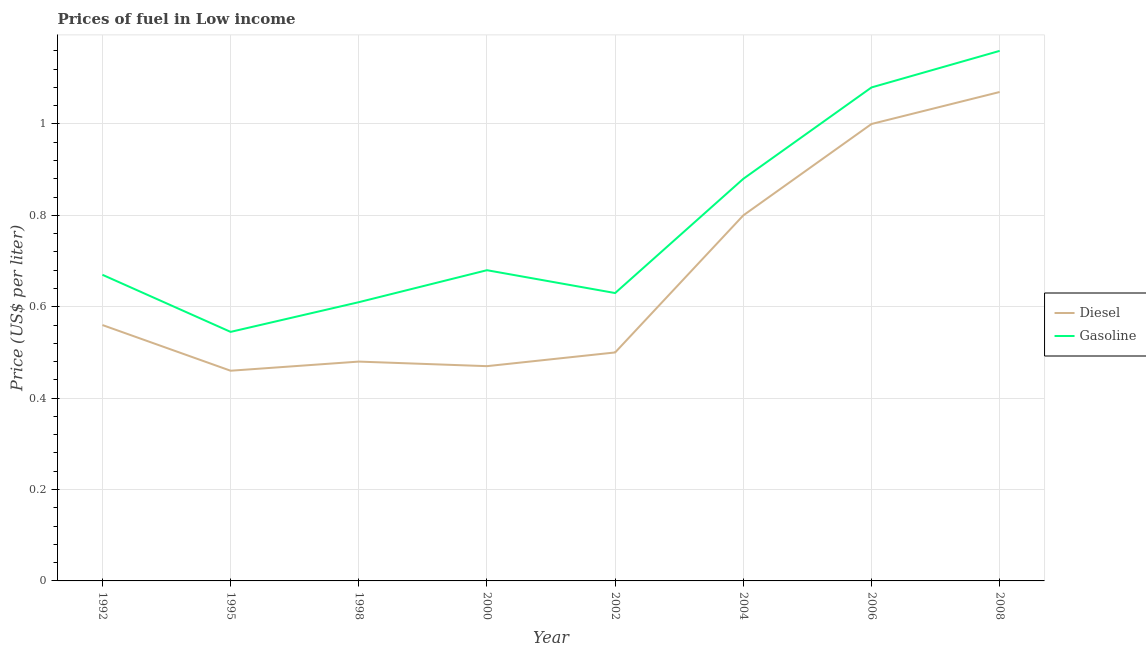How many different coloured lines are there?
Your answer should be compact. 2. What is the diesel price in 1992?
Make the answer very short. 0.56. Across all years, what is the maximum gasoline price?
Offer a very short reply. 1.16. Across all years, what is the minimum diesel price?
Provide a succinct answer. 0.46. In which year was the gasoline price maximum?
Your answer should be very brief. 2008. What is the total gasoline price in the graph?
Provide a short and direct response. 6.25. What is the difference between the gasoline price in 2002 and that in 2006?
Ensure brevity in your answer.  -0.45. What is the difference between the gasoline price in 1992 and the diesel price in 2000?
Ensure brevity in your answer.  0.2. What is the average diesel price per year?
Your answer should be compact. 0.67. In the year 2004, what is the difference between the diesel price and gasoline price?
Offer a very short reply. -0.08. In how many years, is the diesel price greater than 0.8 US$ per litre?
Your response must be concise. 2. What is the ratio of the diesel price in 1995 to that in 1998?
Your answer should be very brief. 0.96. Is the diesel price in 1995 less than that in 2002?
Your answer should be compact. Yes. Is the difference between the gasoline price in 2002 and 2008 greater than the difference between the diesel price in 2002 and 2008?
Offer a very short reply. Yes. What is the difference between the highest and the second highest gasoline price?
Make the answer very short. 0.08. What is the difference between the highest and the lowest gasoline price?
Make the answer very short. 0.61. Does the diesel price monotonically increase over the years?
Make the answer very short. No. Is the gasoline price strictly greater than the diesel price over the years?
Make the answer very short. Yes. Is the gasoline price strictly less than the diesel price over the years?
Provide a short and direct response. No. How many lines are there?
Provide a short and direct response. 2. Does the graph contain grids?
Make the answer very short. Yes. How are the legend labels stacked?
Your answer should be very brief. Vertical. What is the title of the graph?
Offer a very short reply. Prices of fuel in Low income. What is the label or title of the Y-axis?
Give a very brief answer. Price (US$ per liter). What is the Price (US$ per liter) in Diesel in 1992?
Ensure brevity in your answer.  0.56. What is the Price (US$ per liter) in Gasoline in 1992?
Your answer should be compact. 0.67. What is the Price (US$ per liter) of Diesel in 1995?
Offer a very short reply. 0.46. What is the Price (US$ per liter) of Gasoline in 1995?
Offer a terse response. 0.55. What is the Price (US$ per liter) in Diesel in 1998?
Provide a succinct answer. 0.48. What is the Price (US$ per liter) in Gasoline in 1998?
Offer a terse response. 0.61. What is the Price (US$ per liter) in Diesel in 2000?
Your answer should be very brief. 0.47. What is the Price (US$ per liter) in Gasoline in 2000?
Provide a succinct answer. 0.68. What is the Price (US$ per liter) in Gasoline in 2002?
Offer a terse response. 0.63. What is the Price (US$ per liter) in Gasoline in 2004?
Your answer should be very brief. 0.88. What is the Price (US$ per liter) of Diesel in 2006?
Make the answer very short. 1. What is the Price (US$ per liter) in Gasoline in 2006?
Your response must be concise. 1.08. What is the Price (US$ per liter) of Diesel in 2008?
Ensure brevity in your answer.  1.07. What is the Price (US$ per liter) of Gasoline in 2008?
Provide a short and direct response. 1.16. Across all years, what is the maximum Price (US$ per liter) in Diesel?
Make the answer very short. 1.07. Across all years, what is the maximum Price (US$ per liter) of Gasoline?
Ensure brevity in your answer.  1.16. Across all years, what is the minimum Price (US$ per liter) of Diesel?
Give a very brief answer. 0.46. Across all years, what is the minimum Price (US$ per liter) in Gasoline?
Your answer should be compact. 0.55. What is the total Price (US$ per liter) in Diesel in the graph?
Provide a short and direct response. 5.34. What is the total Price (US$ per liter) of Gasoline in the graph?
Provide a succinct answer. 6.25. What is the difference between the Price (US$ per liter) in Gasoline in 1992 and that in 1995?
Give a very brief answer. 0.12. What is the difference between the Price (US$ per liter) in Gasoline in 1992 and that in 1998?
Provide a succinct answer. 0.06. What is the difference between the Price (US$ per liter) of Diesel in 1992 and that in 2000?
Provide a short and direct response. 0.09. What is the difference between the Price (US$ per liter) of Gasoline in 1992 and that in 2000?
Your answer should be compact. -0.01. What is the difference between the Price (US$ per liter) in Diesel in 1992 and that in 2002?
Ensure brevity in your answer.  0.06. What is the difference between the Price (US$ per liter) in Gasoline in 1992 and that in 2002?
Give a very brief answer. 0.04. What is the difference between the Price (US$ per liter) in Diesel in 1992 and that in 2004?
Your answer should be compact. -0.24. What is the difference between the Price (US$ per liter) in Gasoline in 1992 and that in 2004?
Keep it short and to the point. -0.21. What is the difference between the Price (US$ per liter) of Diesel in 1992 and that in 2006?
Offer a very short reply. -0.44. What is the difference between the Price (US$ per liter) of Gasoline in 1992 and that in 2006?
Offer a very short reply. -0.41. What is the difference between the Price (US$ per liter) in Diesel in 1992 and that in 2008?
Your answer should be very brief. -0.51. What is the difference between the Price (US$ per liter) of Gasoline in 1992 and that in 2008?
Your response must be concise. -0.49. What is the difference between the Price (US$ per liter) in Diesel in 1995 and that in 1998?
Your response must be concise. -0.02. What is the difference between the Price (US$ per liter) of Gasoline in 1995 and that in 1998?
Keep it short and to the point. -0.07. What is the difference between the Price (US$ per liter) in Diesel in 1995 and that in 2000?
Your response must be concise. -0.01. What is the difference between the Price (US$ per liter) of Gasoline in 1995 and that in 2000?
Provide a succinct answer. -0.14. What is the difference between the Price (US$ per liter) in Diesel in 1995 and that in 2002?
Your answer should be very brief. -0.04. What is the difference between the Price (US$ per liter) of Gasoline in 1995 and that in 2002?
Give a very brief answer. -0.09. What is the difference between the Price (US$ per liter) in Diesel in 1995 and that in 2004?
Ensure brevity in your answer.  -0.34. What is the difference between the Price (US$ per liter) in Gasoline in 1995 and that in 2004?
Your response must be concise. -0.34. What is the difference between the Price (US$ per liter) of Diesel in 1995 and that in 2006?
Keep it short and to the point. -0.54. What is the difference between the Price (US$ per liter) of Gasoline in 1995 and that in 2006?
Provide a short and direct response. -0.54. What is the difference between the Price (US$ per liter) in Diesel in 1995 and that in 2008?
Keep it short and to the point. -0.61. What is the difference between the Price (US$ per liter) in Gasoline in 1995 and that in 2008?
Your answer should be compact. -0.61. What is the difference between the Price (US$ per liter) of Diesel in 1998 and that in 2000?
Provide a succinct answer. 0.01. What is the difference between the Price (US$ per liter) in Gasoline in 1998 and that in 2000?
Your response must be concise. -0.07. What is the difference between the Price (US$ per liter) of Diesel in 1998 and that in 2002?
Provide a succinct answer. -0.02. What is the difference between the Price (US$ per liter) in Gasoline in 1998 and that in 2002?
Offer a very short reply. -0.02. What is the difference between the Price (US$ per liter) of Diesel in 1998 and that in 2004?
Make the answer very short. -0.32. What is the difference between the Price (US$ per liter) in Gasoline in 1998 and that in 2004?
Offer a terse response. -0.27. What is the difference between the Price (US$ per liter) of Diesel in 1998 and that in 2006?
Give a very brief answer. -0.52. What is the difference between the Price (US$ per liter) of Gasoline in 1998 and that in 2006?
Offer a very short reply. -0.47. What is the difference between the Price (US$ per liter) in Diesel in 1998 and that in 2008?
Give a very brief answer. -0.59. What is the difference between the Price (US$ per liter) in Gasoline in 1998 and that in 2008?
Offer a very short reply. -0.55. What is the difference between the Price (US$ per liter) in Diesel in 2000 and that in 2002?
Provide a short and direct response. -0.03. What is the difference between the Price (US$ per liter) of Gasoline in 2000 and that in 2002?
Keep it short and to the point. 0.05. What is the difference between the Price (US$ per liter) of Diesel in 2000 and that in 2004?
Your response must be concise. -0.33. What is the difference between the Price (US$ per liter) in Diesel in 2000 and that in 2006?
Ensure brevity in your answer.  -0.53. What is the difference between the Price (US$ per liter) in Gasoline in 2000 and that in 2006?
Your answer should be compact. -0.4. What is the difference between the Price (US$ per liter) in Gasoline in 2000 and that in 2008?
Your answer should be compact. -0.48. What is the difference between the Price (US$ per liter) of Gasoline in 2002 and that in 2004?
Provide a succinct answer. -0.25. What is the difference between the Price (US$ per liter) in Diesel in 2002 and that in 2006?
Ensure brevity in your answer.  -0.5. What is the difference between the Price (US$ per liter) of Gasoline in 2002 and that in 2006?
Offer a very short reply. -0.45. What is the difference between the Price (US$ per liter) of Diesel in 2002 and that in 2008?
Ensure brevity in your answer.  -0.57. What is the difference between the Price (US$ per liter) in Gasoline in 2002 and that in 2008?
Ensure brevity in your answer.  -0.53. What is the difference between the Price (US$ per liter) of Diesel in 2004 and that in 2006?
Provide a succinct answer. -0.2. What is the difference between the Price (US$ per liter) in Gasoline in 2004 and that in 2006?
Provide a succinct answer. -0.2. What is the difference between the Price (US$ per liter) in Diesel in 2004 and that in 2008?
Your response must be concise. -0.27. What is the difference between the Price (US$ per liter) in Gasoline in 2004 and that in 2008?
Keep it short and to the point. -0.28. What is the difference between the Price (US$ per liter) of Diesel in 2006 and that in 2008?
Ensure brevity in your answer.  -0.07. What is the difference between the Price (US$ per liter) of Gasoline in 2006 and that in 2008?
Provide a short and direct response. -0.08. What is the difference between the Price (US$ per liter) in Diesel in 1992 and the Price (US$ per liter) in Gasoline in 1995?
Offer a terse response. 0.01. What is the difference between the Price (US$ per liter) of Diesel in 1992 and the Price (US$ per liter) of Gasoline in 1998?
Provide a short and direct response. -0.05. What is the difference between the Price (US$ per liter) of Diesel in 1992 and the Price (US$ per liter) of Gasoline in 2000?
Provide a short and direct response. -0.12. What is the difference between the Price (US$ per liter) in Diesel in 1992 and the Price (US$ per liter) in Gasoline in 2002?
Provide a succinct answer. -0.07. What is the difference between the Price (US$ per liter) in Diesel in 1992 and the Price (US$ per liter) in Gasoline in 2004?
Your response must be concise. -0.32. What is the difference between the Price (US$ per liter) of Diesel in 1992 and the Price (US$ per liter) of Gasoline in 2006?
Offer a very short reply. -0.52. What is the difference between the Price (US$ per liter) in Diesel in 1995 and the Price (US$ per liter) in Gasoline in 1998?
Offer a very short reply. -0.15. What is the difference between the Price (US$ per liter) of Diesel in 1995 and the Price (US$ per liter) of Gasoline in 2000?
Ensure brevity in your answer.  -0.22. What is the difference between the Price (US$ per liter) of Diesel in 1995 and the Price (US$ per liter) of Gasoline in 2002?
Your answer should be very brief. -0.17. What is the difference between the Price (US$ per liter) in Diesel in 1995 and the Price (US$ per liter) in Gasoline in 2004?
Keep it short and to the point. -0.42. What is the difference between the Price (US$ per liter) in Diesel in 1995 and the Price (US$ per liter) in Gasoline in 2006?
Give a very brief answer. -0.62. What is the difference between the Price (US$ per liter) of Diesel in 1995 and the Price (US$ per liter) of Gasoline in 2008?
Make the answer very short. -0.7. What is the difference between the Price (US$ per liter) of Diesel in 1998 and the Price (US$ per liter) of Gasoline in 2000?
Keep it short and to the point. -0.2. What is the difference between the Price (US$ per liter) in Diesel in 1998 and the Price (US$ per liter) in Gasoline in 2004?
Your response must be concise. -0.4. What is the difference between the Price (US$ per liter) in Diesel in 1998 and the Price (US$ per liter) in Gasoline in 2008?
Offer a terse response. -0.68. What is the difference between the Price (US$ per liter) in Diesel in 2000 and the Price (US$ per liter) in Gasoline in 2002?
Provide a short and direct response. -0.16. What is the difference between the Price (US$ per liter) of Diesel in 2000 and the Price (US$ per liter) of Gasoline in 2004?
Ensure brevity in your answer.  -0.41. What is the difference between the Price (US$ per liter) in Diesel in 2000 and the Price (US$ per liter) in Gasoline in 2006?
Give a very brief answer. -0.61. What is the difference between the Price (US$ per liter) of Diesel in 2000 and the Price (US$ per liter) of Gasoline in 2008?
Your response must be concise. -0.69. What is the difference between the Price (US$ per liter) in Diesel in 2002 and the Price (US$ per liter) in Gasoline in 2004?
Offer a very short reply. -0.38. What is the difference between the Price (US$ per liter) in Diesel in 2002 and the Price (US$ per liter) in Gasoline in 2006?
Make the answer very short. -0.58. What is the difference between the Price (US$ per liter) of Diesel in 2002 and the Price (US$ per liter) of Gasoline in 2008?
Give a very brief answer. -0.66. What is the difference between the Price (US$ per liter) of Diesel in 2004 and the Price (US$ per liter) of Gasoline in 2006?
Ensure brevity in your answer.  -0.28. What is the difference between the Price (US$ per liter) in Diesel in 2004 and the Price (US$ per liter) in Gasoline in 2008?
Offer a terse response. -0.36. What is the difference between the Price (US$ per liter) of Diesel in 2006 and the Price (US$ per liter) of Gasoline in 2008?
Keep it short and to the point. -0.16. What is the average Price (US$ per liter) in Diesel per year?
Ensure brevity in your answer.  0.67. What is the average Price (US$ per liter) in Gasoline per year?
Your answer should be compact. 0.78. In the year 1992, what is the difference between the Price (US$ per liter) of Diesel and Price (US$ per liter) of Gasoline?
Your answer should be compact. -0.11. In the year 1995, what is the difference between the Price (US$ per liter) of Diesel and Price (US$ per liter) of Gasoline?
Provide a succinct answer. -0.09. In the year 1998, what is the difference between the Price (US$ per liter) of Diesel and Price (US$ per liter) of Gasoline?
Provide a short and direct response. -0.13. In the year 2000, what is the difference between the Price (US$ per liter) in Diesel and Price (US$ per liter) in Gasoline?
Your response must be concise. -0.21. In the year 2002, what is the difference between the Price (US$ per liter) of Diesel and Price (US$ per liter) of Gasoline?
Make the answer very short. -0.13. In the year 2004, what is the difference between the Price (US$ per liter) in Diesel and Price (US$ per liter) in Gasoline?
Your answer should be compact. -0.08. In the year 2006, what is the difference between the Price (US$ per liter) of Diesel and Price (US$ per liter) of Gasoline?
Your answer should be very brief. -0.08. In the year 2008, what is the difference between the Price (US$ per liter) in Diesel and Price (US$ per liter) in Gasoline?
Your answer should be very brief. -0.09. What is the ratio of the Price (US$ per liter) of Diesel in 1992 to that in 1995?
Give a very brief answer. 1.22. What is the ratio of the Price (US$ per liter) in Gasoline in 1992 to that in 1995?
Ensure brevity in your answer.  1.23. What is the ratio of the Price (US$ per liter) in Diesel in 1992 to that in 1998?
Provide a short and direct response. 1.17. What is the ratio of the Price (US$ per liter) in Gasoline in 1992 to that in 1998?
Your answer should be compact. 1.1. What is the ratio of the Price (US$ per liter) of Diesel in 1992 to that in 2000?
Provide a succinct answer. 1.19. What is the ratio of the Price (US$ per liter) in Gasoline in 1992 to that in 2000?
Your answer should be compact. 0.99. What is the ratio of the Price (US$ per liter) of Diesel in 1992 to that in 2002?
Your response must be concise. 1.12. What is the ratio of the Price (US$ per liter) of Gasoline in 1992 to that in 2002?
Provide a succinct answer. 1.06. What is the ratio of the Price (US$ per liter) in Diesel in 1992 to that in 2004?
Ensure brevity in your answer.  0.7. What is the ratio of the Price (US$ per liter) of Gasoline in 1992 to that in 2004?
Make the answer very short. 0.76. What is the ratio of the Price (US$ per liter) in Diesel in 1992 to that in 2006?
Give a very brief answer. 0.56. What is the ratio of the Price (US$ per liter) in Gasoline in 1992 to that in 2006?
Give a very brief answer. 0.62. What is the ratio of the Price (US$ per liter) in Diesel in 1992 to that in 2008?
Your answer should be very brief. 0.52. What is the ratio of the Price (US$ per liter) of Gasoline in 1992 to that in 2008?
Provide a succinct answer. 0.58. What is the ratio of the Price (US$ per liter) in Gasoline in 1995 to that in 1998?
Offer a very short reply. 0.89. What is the ratio of the Price (US$ per liter) of Diesel in 1995 to that in 2000?
Provide a short and direct response. 0.98. What is the ratio of the Price (US$ per liter) of Gasoline in 1995 to that in 2000?
Provide a short and direct response. 0.8. What is the ratio of the Price (US$ per liter) of Diesel in 1995 to that in 2002?
Your answer should be compact. 0.92. What is the ratio of the Price (US$ per liter) in Gasoline in 1995 to that in 2002?
Your response must be concise. 0.87. What is the ratio of the Price (US$ per liter) in Diesel in 1995 to that in 2004?
Your response must be concise. 0.57. What is the ratio of the Price (US$ per liter) in Gasoline in 1995 to that in 2004?
Make the answer very short. 0.62. What is the ratio of the Price (US$ per liter) of Diesel in 1995 to that in 2006?
Offer a terse response. 0.46. What is the ratio of the Price (US$ per liter) of Gasoline in 1995 to that in 2006?
Offer a very short reply. 0.5. What is the ratio of the Price (US$ per liter) of Diesel in 1995 to that in 2008?
Offer a terse response. 0.43. What is the ratio of the Price (US$ per liter) of Gasoline in 1995 to that in 2008?
Offer a very short reply. 0.47. What is the ratio of the Price (US$ per liter) in Diesel in 1998 to that in 2000?
Make the answer very short. 1.02. What is the ratio of the Price (US$ per liter) of Gasoline in 1998 to that in 2000?
Offer a very short reply. 0.9. What is the ratio of the Price (US$ per liter) of Diesel in 1998 to that in 2002?
Give a very brief answer. 0.96. What is the ratio of the Price (US$ per liter) in Gasoline in 1998 to that in 2002?
Give a very brief answer. 0.97. What is the ratio of the Price (US$ per liter) of Gasoline in 1998 to that in 2004?
Make the answer very short. 0.69. What is the ratio of the Price (US$ per liter) of Diesel in 1998 to that in 2006?
Give a very brief answer. 0.48. What is the ratio of the Price (US$ per liter) of Gasoline in 1998 to that in 2006?
Keep it short and to the point. 0.56. What is the ratio of the Price (US$ per liter) in Diesel in 1998 to that in 2008?
Ensure brevity in your answer.  0.45. What is the ratio of the Price (US$ per liter) in Gasoline in 1998 to that in 2008?
Your answer should be very brief. 0.53. What is the ratio of the Price (US$ per liter) of Diesel in 2000 to that in 2002?
Your response must be concise. 0.94. What is the ratio of the Price (US$ per liter) of Gasoline in 2000 to that in 2002?
Your answer should be very brief. 1.08. What is the ratio of the Price (US$ per liter) of Diesel in 2000 to that in 2004?
Your response must be concise. 0.59. What is the ratio of the Price (US$ per liter) of Gasoline in 2000 to that in 2004?
Provide a succinct answer. 0.77. What is the ratio of the Price (US$ per liter) in Diesel in 2000 to that in 2006?
Keep it short and to the point. 0.47. What is the ratio of the Price (US$ per liter) in Gasoline in 2000 to that in 2006?
Provide a succinct answer. 0.63. What is the ratio of the Price (US$ per liter) in Diesel in 2000 to that in 2008?
Offer a very short reply. 0.44. What is the ratio of the Price (US$ per liter) in Gasoline in 2000 to that in 2008?
Provide a short and direct response. 0.59. What is the ratio of the Price (US$ per liter) in Gasoline in 2002 to that in 2004?
Keep it short and to the point. 0.72. What is the ratio of the Price (US$ per liter) of Diesel in 2002 to that in 2006?
Your answer should be compact. 0.5. What is the ratio of the Price (US$ per liter) of Gasoline in 2002 to that in 2006?
Your answer should be very brief. 0.58. What is the ratio of the Price (US$ per liter) in Diesel in 2002 to that in 2008?
Offer a terse response. 0.47. What is the ratio of the Price (US$ per liter) in Gasoline in 2002 to that in 2008?
Make the answer very short. 0.54. What is the ratio of the Price (US$ per liter) of Gasoline in 2004 to that in 2006?
Offer a very short reply. 0.81. What is the ratio of the Price (US$ per liter) of Diesel in 2004 to that in 2008?
Make the answer very short. 0.75. What is the ratio of the Price (US$ per liter) in Gasoline in 2004 to that in 2008?
Provide a short and direct response. 0.76. What is the ratio of the Price (US$ per liter) of Diesel in 2006 to that in 2008?
Your answer should be compact. 0.93. What is the ratio of the Price (US$ per liter) of Gasoline in 2006 to that in 2008?
Give a very brief answer. 0.93. What is the difference between the highest and the second highest Price (US$ per liter) in Diesel?
Provide a succinct answer. 0.07. What is the difference between the highest and the second highest Price (US$ per liter) of Gasoline?
Offer a very short reply. 0.08. What is the difference between the highest and the lowest Price (US$ per liter) of Diesel?
Offer a terse response. 0.61. What is the difference between the highest and the lowest Price (US$ per liter) of Gasoline?
Your response must be concise. 0.61. 